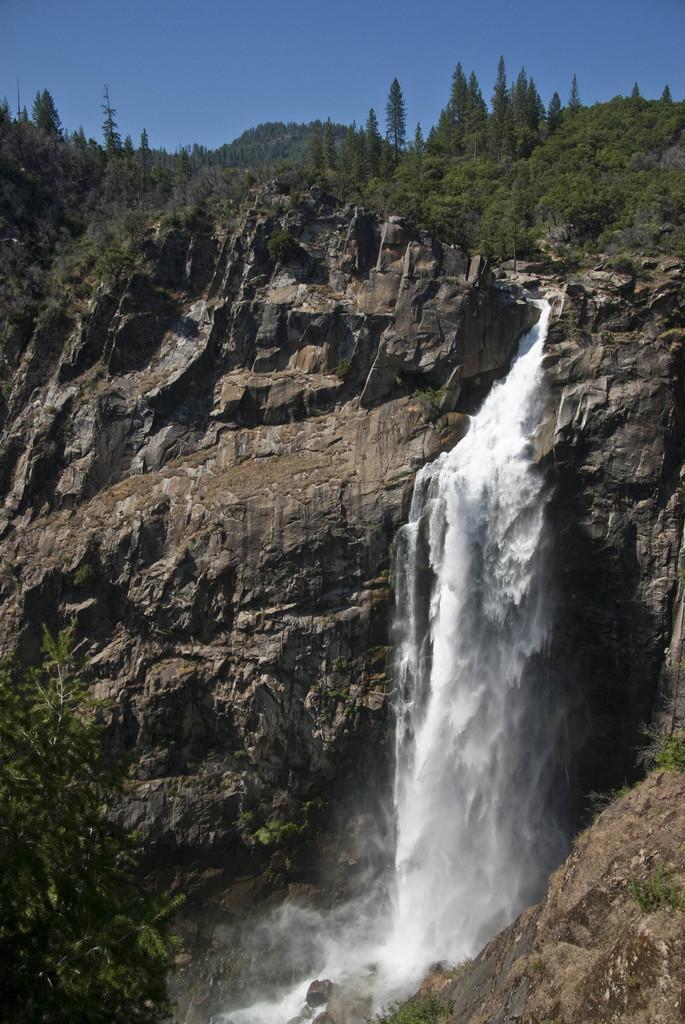Could you give a brief overview of what you see in this image? This image is taken outdoors. At the top of the image there is the sky. In the middle of the image there are many rocks. There is a waterfall with water. There are many trees and plants on the ground. 